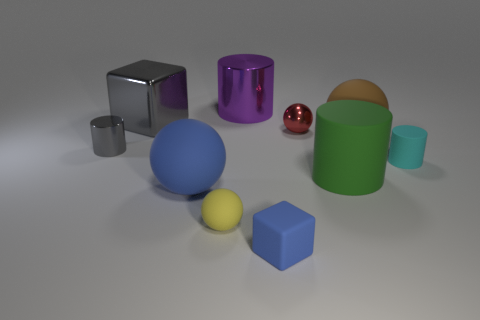Subtract all spheres. How many objects are left? 6 Subtract all small matte things. Subtract all yellow spheres. How many objects are left? 6 Add 3 big cylinders. How many big cylinders are left? 5 Add 9 small gray cylinders. How many small gray cylinders exist? 10 Subtract 1 gray cylinders. How many objects are left? 9 